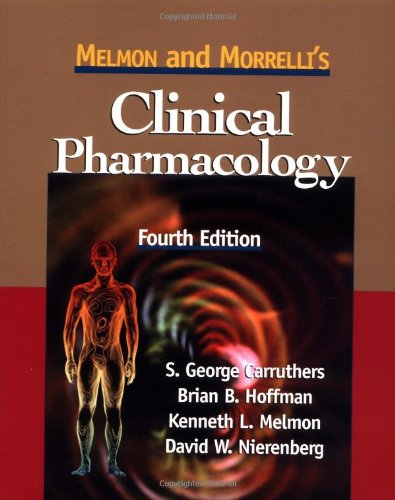Who wrote this book? The book 'Melmon and Morrelli's Clinical Pharmacology' was authored by S. George Carruthers, along with Brian B. Hoffman, Kenneth L. Melmon, and David W. Nierenberg. 